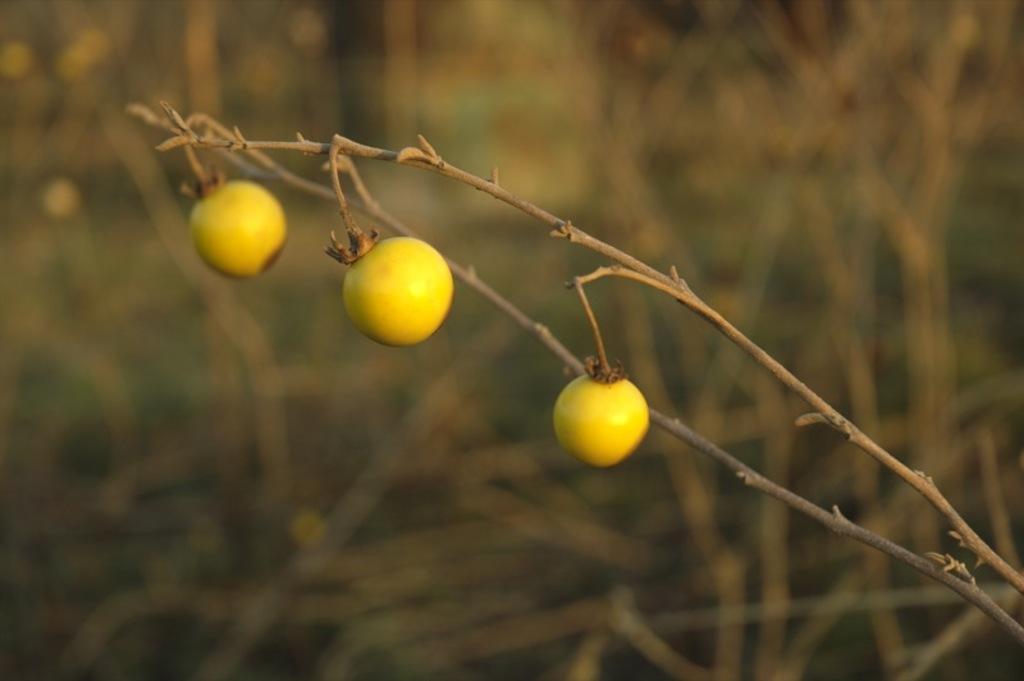Could you give a brief overview of what you see in this image? In this image, we can see fruits to a stem and the background is blurry. 